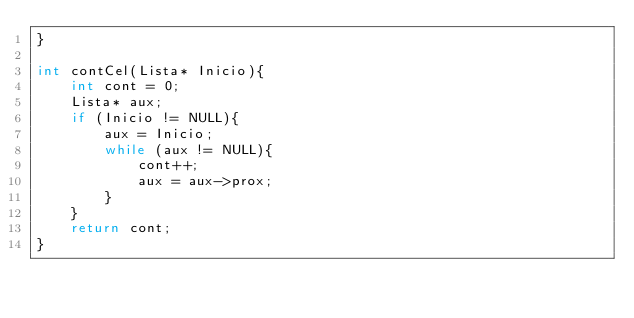Convert code to text. <code><loc_0><loc_0><loc_500><loc_500><_C++_>}

int contCel(Lista* Inicio){
	int cont = 0;
	Lista* aux;
	if (Inicio != NULL){
		aux = Inicio;
		while (aux != NULL){
			cont++;
			aux = aux->prox;
		}
	}
	return cont;
}
</code> 